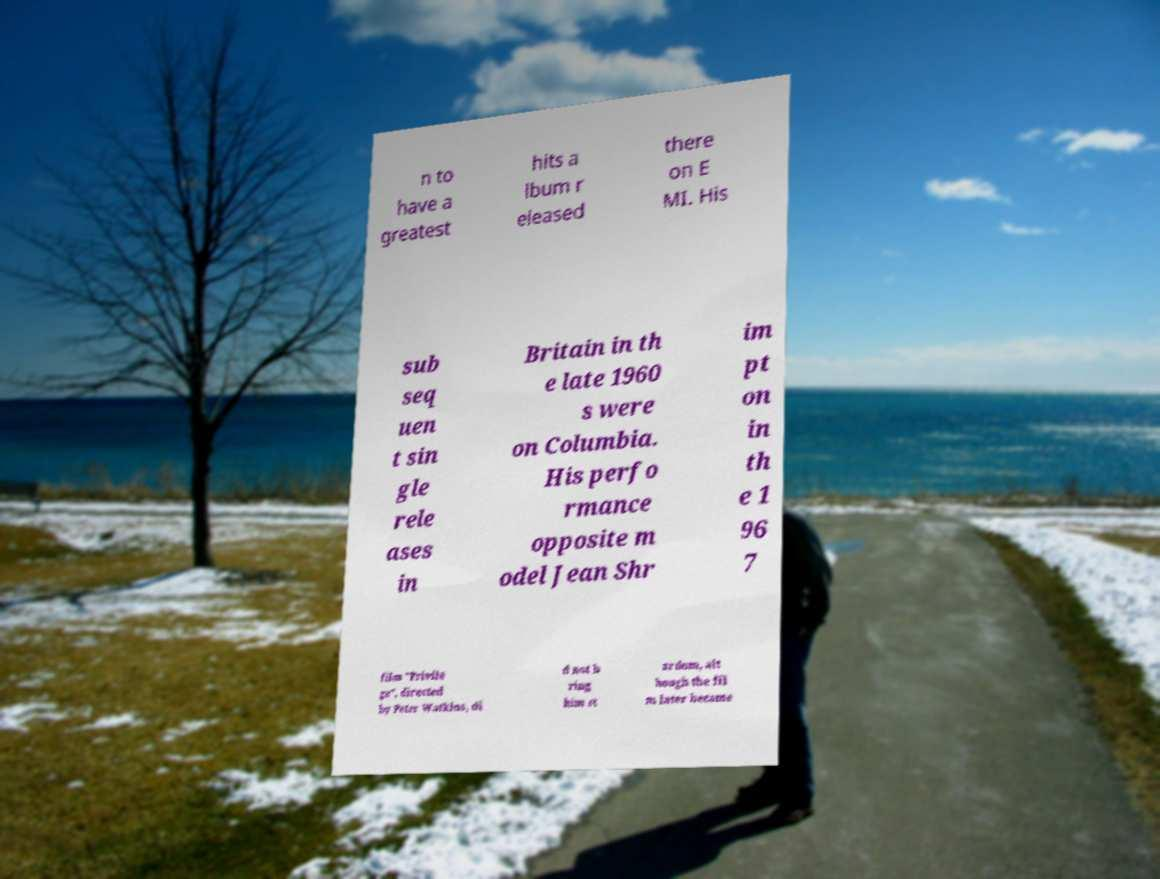For documentation purposes, I need the text within this image transcribed. Could you provide that? n to have a greatest hits a lbum r eleased there on E MI. His sub seq uen t sin gle rele ases in Britain in th e late 1960 s were on Columbia. His perfo rmance opposite m odel Jean Shr im pt on in th e 1 96 7 film "Privile ge", directed by Peter Watkins, di d not b ring him st ardom, alt hough the fil m later became 